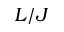Convert formula to latex. <formula><loc_0><loc_0><loc_500><loc_500>L / J</formula> 